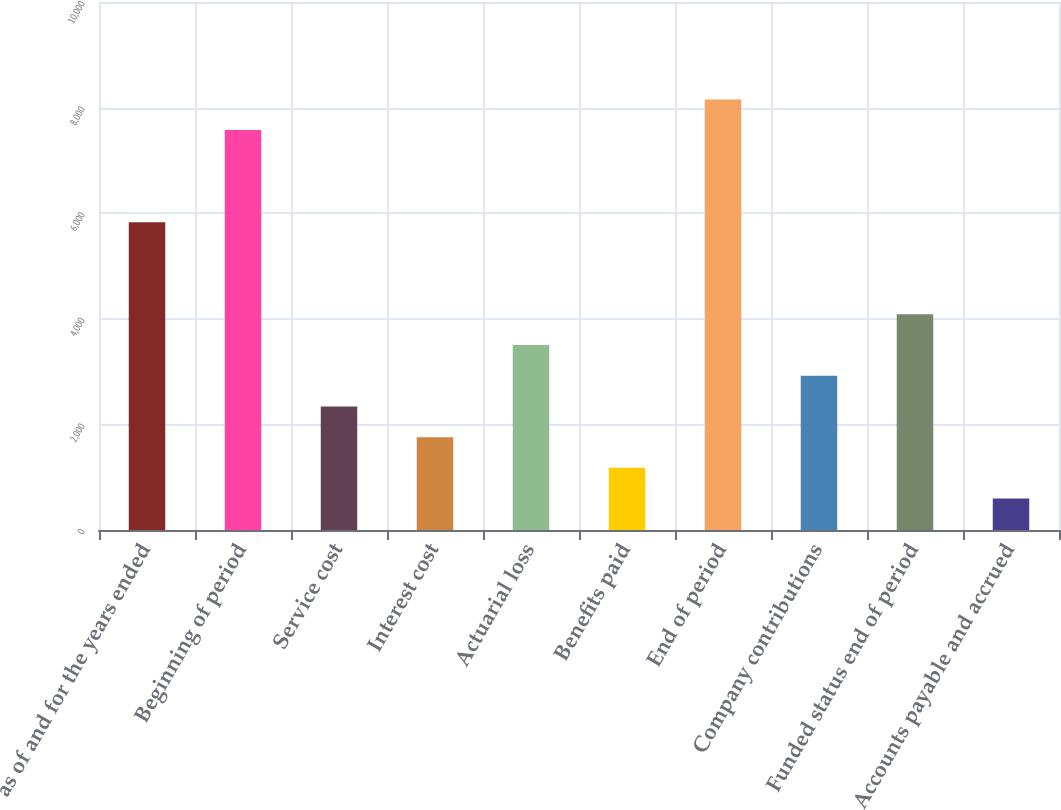<chart> <loc_0><loc_0><loc_500><loc_500><bar_chart><fcel>as of and for the years ended<fcel>Beginning of period<fcel>Service cost<fcel>Interest cost<fcel>Actuarial loss<fcel>Benefits paid<fcel>End of period<fcel>Company contributions<fcel>Funded status end of period<fcel>Accounts payable and accrued<nl><fcel>5829<fcel>7573.5<fcel>2340<fcel>1758.5<fcel>3503<fcel>1177<fcel>8155<fcel>2921.5<fcel>4084.5<fcel>595.5<nl></chart> 